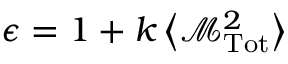<formula> <loc_0><loc_0><loc_500><loc_500>\epsilon = 1 + k \left \langle { \mathcal { M } } _ { T o t } ^ { 2 } \right \rangle</formula> 